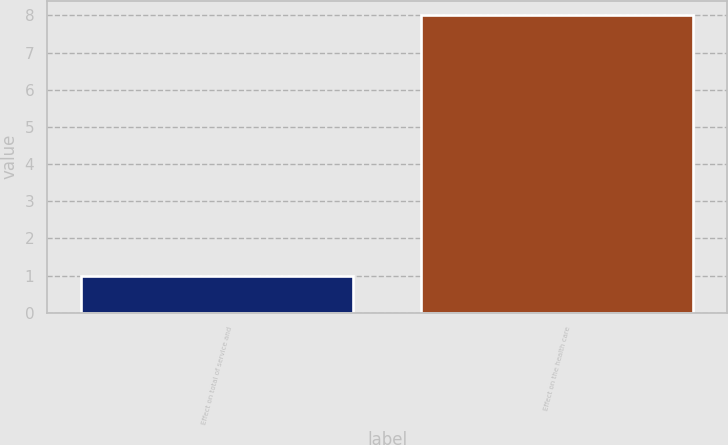Convert chart. <chart><loc_0><loc_0><loc_500><loc_500><bar_chart><fcel>Effect on total of service and<fcel>Effect on the health care<nl><fcel>1<fcel>8<nl></chart> 